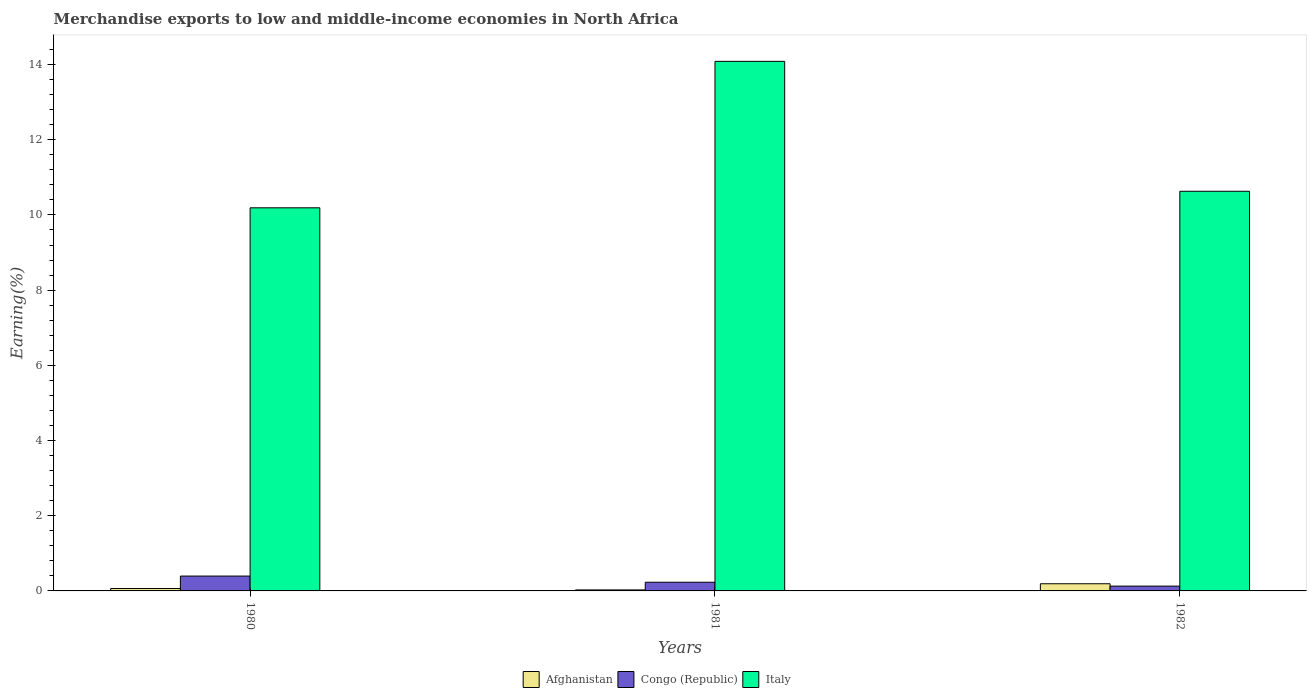How many different coloured bars are there?
Give a very brief answer. 3. How many groups of bars are there?
Keep it short and to the point. 3. Are the number of bars per tick equal to the number of legend labels?
Your answer should be compact. Yes. Are the number of bars on each tick of the X-axis equal?
Ensure brevity in your answer.  Yes. How many bars are there on the 3rd tick from the left?
Your answer should be very brief. 3. What is the label of the 1st group of bars from the left?
Ensure brevity in your answer.  1980. What is the percentage of amount earned from merchandise exports in Congo (Republic) in 1981?
Make the answer very short. 0.23. Across all years, what is the maximum percentage of amount earned from merchandise exports in Italy?
Keep it short and to the point. 14.08. Across all years, what is the minimum percentage of amount earned from merchandise exports in Italy?
Ensure brevity in your answer.  10.19. In which year was the percentage of amount earned from merchandise exports in Congo (Republic) minimum?
Keep it short and to the point. 1982. What is the total percentage of amount earned from merchandise exports in Italy in the graph?
Your response must be concise. 34.9. What is the difference between the percentage of amount earned from merchandise exports in Italy in 1980 and that in 1981?
Your answer should be very brief. -3.89. What is the difference between the percentage of amount earned from merchandise exports in Afghanistan in 1982 and the percentage of amount earned from merchandise exports in Italy in 1980?
Give a very brief answer. -10. What is the average percentage of amount earned from merchandise exports in Italy per year?
Offer a very short reply. 11.63. In the year 1981, what is the difference between the percentage of amount earned from merchandise exports in Italy and percentage of amount earned from merchandise exports in Afghanistan?
Offer a very short reply. 14.06. What is the ratio of the percentage of amount earned from merchandise exports in Italy in 1980 to that in 1982?
Give a very brief answer. 0.96. Is the difference between the percentage of amount earned from merchandise exports in Italy in 1980 and 1981 greater than the difference between the percentage of amount earned from merchandise exports in Afghanistan in 1980 and 1981?
Your response must be concise. No. What is the difference between the highest and the second highest percentage of amount earned from merchandise exports in Afghanistan?
Your response must be concise. 0.13. What is the difference between the highest and the lowest percentage of amount earned from merchandise exports in Italy?
Keep it short and to the point. 3.89. In how many years, is the percentage of amount earned from merchandise exports in Italy greater than the average percentage of amount earned from merchandise exports in Italy taken over all years?
Provide a short and direct response. 1. Is the sum of the percentage of amount earned from merchandise exports in Afghanistan in 1980 and 1982 greater than the maximum percentage of amount earned from merchandise exports in Congo (Republic) across all years?
Your answer should be very brief. No. What does the 3rd bar from the left in 1980 represents?
Your answer should be very brief. Italy. What does the 2nd bar from the right in 1980 represents?
Your answer should be compact. Congo (Republic). Is it the case that in every year, the sum of the percentage of amount earned from merchandise exports in Italy and percentage of amount earned from merchandise exports in Congo (Republic) is greater than the percentage of amount earned from merchandise exports in Afghanistan?
Ensure brevity in your answer.  Yes. Are all the bars in the graph horizontal?
Offer a very short reply. No. How many years are there in the graph?
Your response must be concise. 3. What is the difference between two consecutive major ticks on the Y-axis?
Your answer should be very brief. 2. Are the values on the major ticks of Y-axis written in scientific E-notation?
Provide a short and direct response. No. Does the graph contain any zero values?
Ensure brevity in your answer.  No. How many legend labels are there?
Provide a short and direct response. 3. How are the legend labels stacked?
Your response must be concise. Horizontal. What is the title of the graph?
Ensure brevity in your answer.  Merchandise exports to low and middle-income economies in North Africa. Does "Northern Mariana Islands" appear as one of the legend labels in the graph?
Provide a short and direct response. No. What is the label or title of the X-axis?
Keep it short and to the point. Years. What is the label or title of the Y-axis?
Your answer should be compact. Earning(%). What is the Earning(%) in Afghanistan in 1980?
Ensure brevity in your answer.  0.06. What is the Earning(%) in Congo (Republic) in 1980?
Provide a succinct answer. 0.39. What is the Earning(%) of Italy in 1980?
Ensure brevity in your answer.  10.19. What is the Earning(%) in Afghanistan in 1981?
Give a very brief answer. 0.03. What is the Earning(%) in Congo (Republic) in 1981?
Your response must be concise. 0.23. What is the Earning(%) in Italy in 1981?
Provide a succinct answer. 14.08. What is the Earning(%) of Afghanistan in 1982?
Your response must be concise. 0.19. What is the Earning(%) of Congo (Republic) in 1982?
Keep it short and to the point. 0.13. What is the Earning(%) of Italy in 1982?
Make the answer very short. 10.63. Across all years, what is the maximum Earning(%) of Afghanistan?
Offer a terse response. 0.19. Across all years, what is the maximum Earning(%) of Congo (Republic)?
Ensure brevity in your answer.  0.39. Across all years, what is the maximum Earning(%) in Italy?
Your response must be concise. 14.08. Across all years, what is the minimum Earning(%) of Afghanistan?
Provide a short and direct response. 0.03. Across all years, what is the minimum Earning(%) in Congo (Republic)?
Your answer should be compact. 0.13. Across all years, what is the minimum Earning(%) in Italy?
Your response must be concise. 10.19. What is the total Earning(%) of Afghanistan in the graph?
Make the answer very short. 0.28. What is the total Earning(%) in Congo (Republic) in the graph?
Offer a very short reply. 0.75. What is the total Earning(%) of Italy in the graph?
Provide a short and direct response. 34.9. What is the difference between the Earning(%) in Afghanistan in 1980 and that in 1981?
Your response must be concise. 0.04. What is the difference between the Earning(%) of Congo (Republic) in 1980 and that in 1981?
Provide a short and direct response. 0.16. What is the difference between the Earning(%) in Italy in 1980 and that in 1981?
Your answer should be very brief. -3.9. What is the difference between the Earning(%) in Afghanistan in 1980 and that in 1982?
Your answer should be compact. -0.13. What is the difference between the Earning(%) in Congo (Republic) in 1980 and that in 1982?
Your answer should be very brief. 0.27. What is the difference between the Earning(%) of Italy in 1980 and that in 1982?
Your answer should be very brief. -0.44. What is the difference between the Earning(%) of Afghanistan in 1981 and that in 1982?
Your answer should be compact. -0.16. What is the difference between the Earning(%) of Congo (Republic) in 1981 and that in 1982?
Offer a terse response. 0.1. What is the difference between the Earning(%) of Italy in 1981 and that in 1982?
Provide a succinct answer. 3.46. What is the difference between the Earning(%) of Afghanistan in 1980 and the Earning(%) of Congo (Republic) in 1981?
Keep it short and to the point. -0.17. What is the difference between the Earning(%) of Afghanistan in 1980 and the Earning(%) of Italy in 1981?
Provide a short and direct response. -14.02. What is the difference between the Earning(%) in Congo (Republic) in 1980 and the Earning(%) in Italy in 1981?
Ensure brevity in your answer.  -13.69. What is the difference between the Earning(%) in Afghanistan in 1980 and the Earning(%) in Congo (Republic) in 1982?
Ensure brevity in your answer.  -0.06. What is the difference between the Earning(%) in Afghanistan in 1980 and the Earning(%) in Italy in 1982?
Ensure brevity in your answer.  -10.56. What is the difference between the Earning(%) in Congo (Republic) in 1980 and the Earning(%) in Italy in 1982?
Ensure brevity in your answer.  -10.23. What is the difference between the Earning(%) in Afghanistan in 1981 and the Earning(%) in Congo (Republic) in 1982?
Make the answer very short. -0.1. What is the difference between the Earning(%) of Afghanistan in 1981 and the Earning(%) of Italy in 1982?
Ensure brevity in your answer.  -10.6. What is the difference between the Earning(%) of Congo (Republic) in 1981 and the Earning(%) of Italy in 1982?
Ensure brevity in your answer.  -10.4. What is the average Earning(%) in Afghanistan per year?
Offer a terse response. 0.09. What is the average Earning(%) in Congo (Republic) per year?
Make the answer very short. 0.25. What is the average Earning(%) in Italy per year?
Provide a short and direct response. 11.63. In the year 1980, what is the difference between the Earning(%) of Afghanistan and Earning(%) of Congo (Republic)?
Offer a very short reply. -0.33. In the year 1980, what is the difference between the Earning(%) in Afghanistan and Earning(%) in Italy?
Offer a very short reply. -10.12. In the year 1980, what is the difference between the Earning(%) in Congo (Republic) and Earning(%) in Italy?
Keep it short and to the point. -9.79. In the year 1981, what is the difference between the Earning(%) of Afghanistan and Earning(%) of Congo (Republic)?
Your response must be concise. -0.2. In the year 1981, what is the difference between the Earning(%) in Afghanistan and Earning(%) in Italy?
Offer a very short reply. -14.06. In the year 1981, what is the difference between the Earning(%) in Congo (Republic) and Earning(%) in Italy?
Ensure brevity in your answer.  -13.85. In the year 1982, what is the difference between the Earning(%) of Afghanistan and Earning(%) of Congo (Republic)?
Your answer should be very brief. 0.06. In the year 1982, what is the difference between the Earning(%) of Afghanistan and Earning(%) of Italy?
Your response must be concise. -10.44. In the year 1982, what is the difference between the Earning(%) of Congo (Republic) and Earning(%) of Italy?
Provide a succinct answer. -10.5. What is the ratio of the Earning(%) of Afghanistan in 1980 to that in 1981?
Ensure brevity in your answer.  2.39. What is the ratio of the Earning(%) in Congo (Republic) in 1980 to that in 1981?
Your answer should be compact. 1.71. What is the ratio of the Earning(%) of Italy in 1980 to that in 1981?
Provide a short and direct response. 0.72. What is the ratio of the Earning(%) of Afghanistan in 1980 to that in 1982?
Provide a short and direct response. 0.34. What is the ratio of the Earning(%) in Congo (Republic) in 1980 to that in 1982?
Offer a very short reply. 3.09. What is the ratio of the Earning(%) in Italy in 1980 to that in 1982?
Keep it short and to the point. 0.96. What is the ratio of the Earning(%) in Afghanistan in 1981 to that in 1982?
Keep it short and to the point. 0.14. What is the ratio of the Earning(%) of Congo (Republic) in 1981 to that in 1982?
Your answer should be compact. 1.8. What is the ratio of the Earning(%) in Italy in 1981 to that in 1982?
Offer a very short reply. 1.33. What is the difference between the highest and the second highest Earning(%) in Afghanistan?
Make the answer very short. 0.13. What is the difference between the highest and the second highest Earning(%) of Congo (Republic)?
Your answer should be compact. 0.16. What is the difference between the highest and the second highest Earning(%) in Italy?
Your answer should be compact. 3.46. What is the difference between the highest and the lowest Earning(%) of Afghanistan?
Your answer should be compact. 0.16. What is the difference between the highest and the lowest Earning(%) in Congo (Republic)?
Your response must be concise. 0.27. What is the difference between the highest and the lowest Earning(%) of Italy?
Keep it short and to the point. 3.9. 